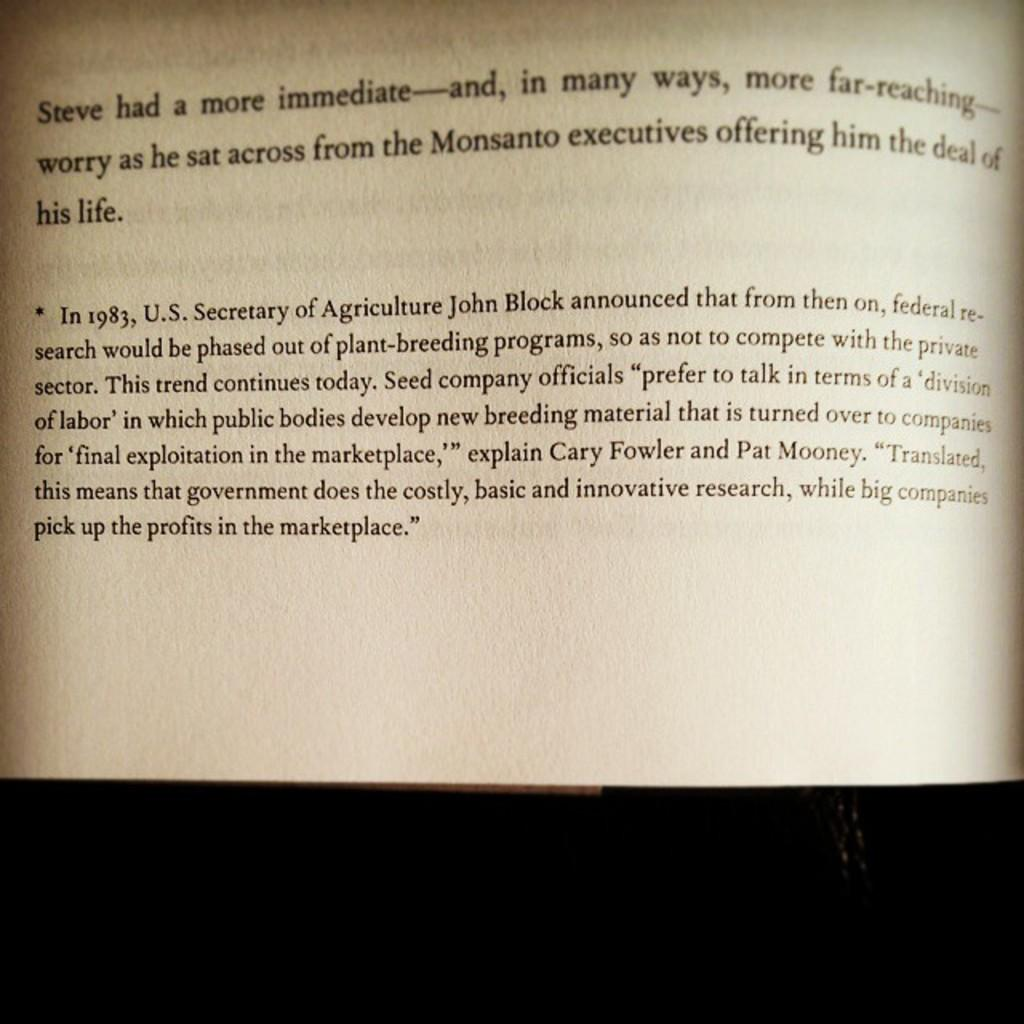<image>
Write a terse but informative summary of the picture. A page of a book which is talking about Steve and the deal of his life. 